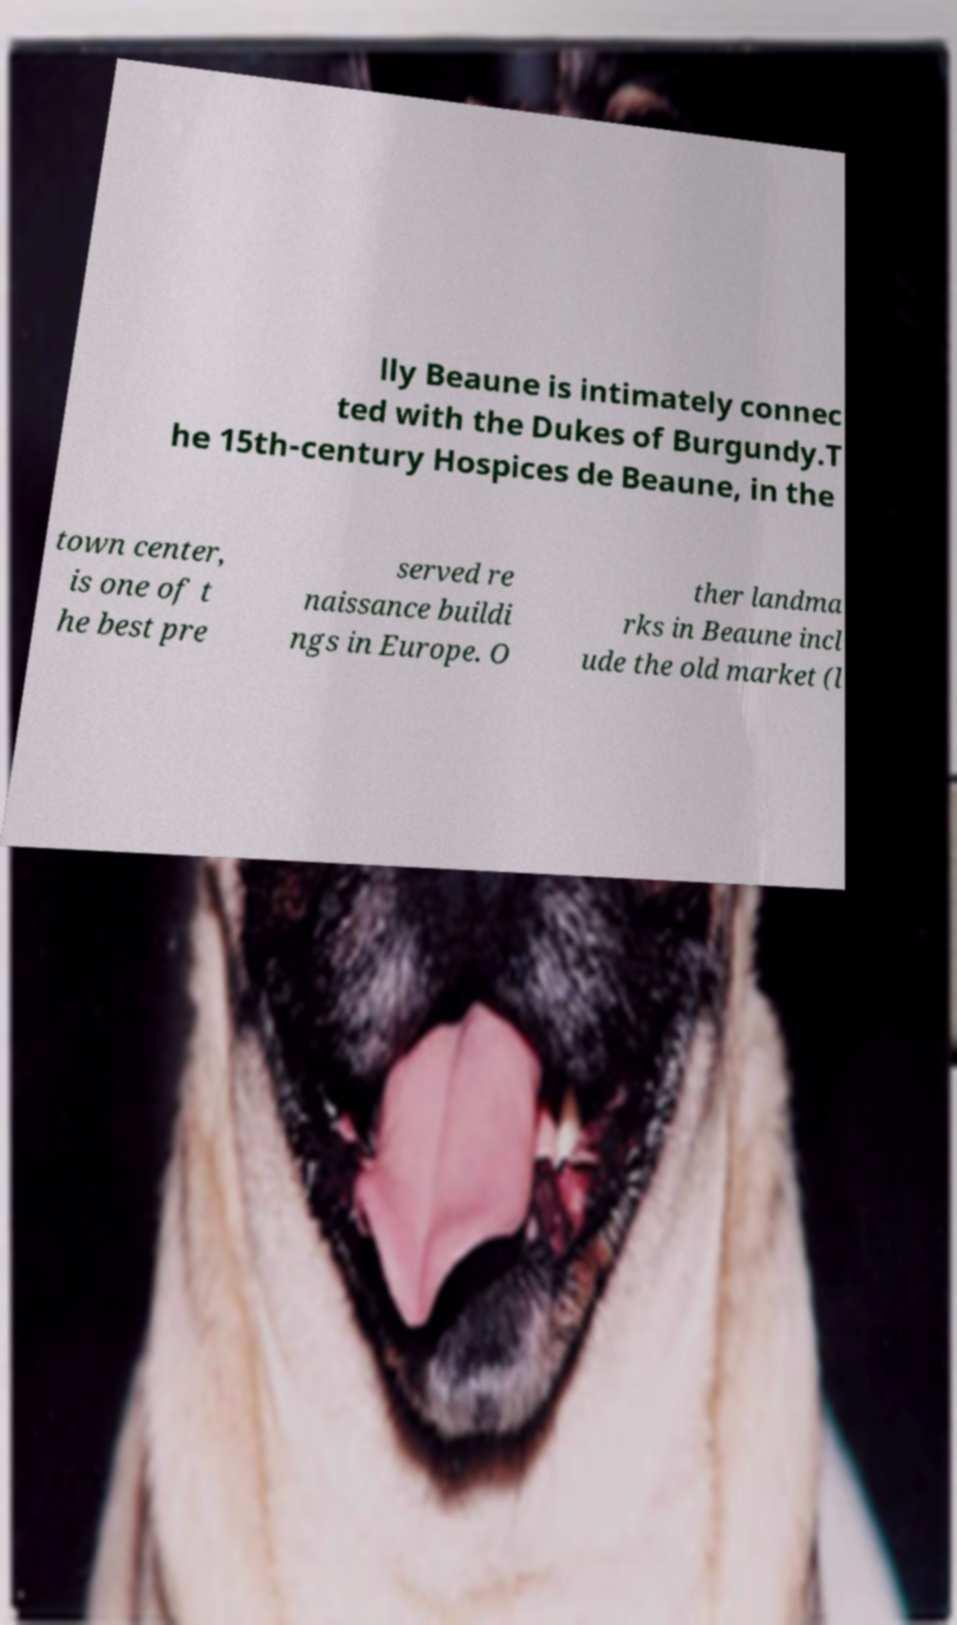Please identify and transcribe the text found in this image. lly Beaune is intimately connec ted with the Dukes of Burgundy.T he 15th-century Hospices de Beaune, in the town center, is one of t he best pre served re naissance buildi ngs in Europe. O ther landma rks in Beaune incl ude the old market (l 